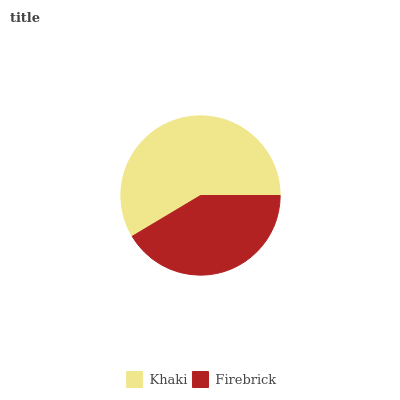Is Firebrick the minimum?
Answer yes or no. Yes. Is Khaki the maximum?
Answer yes or no. Yes. Is Firebrick the maximum?
Answer yes or no. No. Is Khaki greater than Firebrick?
Answer yes or no. Yes. Is Firebrick less than Khaki?
Answer yes or no. Yes. Is Firebrick greater than Khaki?
Answer yes or no. No. Is Khaki less than Firebrick?
Answer yes or no. No. Is Khaki the high median?
Answer yes or no. Yes. Is Firebrick the low median?
Answer yes or no. Yes. Is Firebrick the high median?
Answer yes or no. No. Is Khaki the low median?
Answer yes or no. No. 